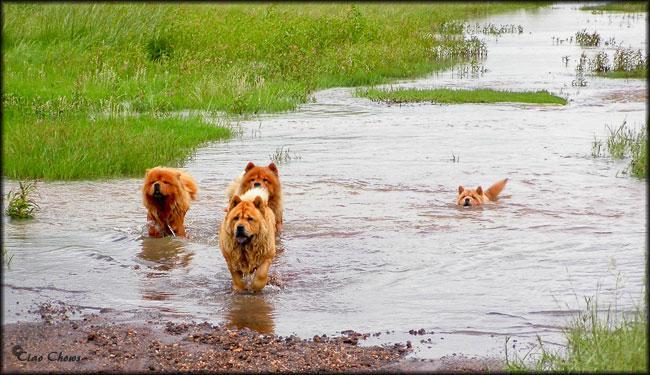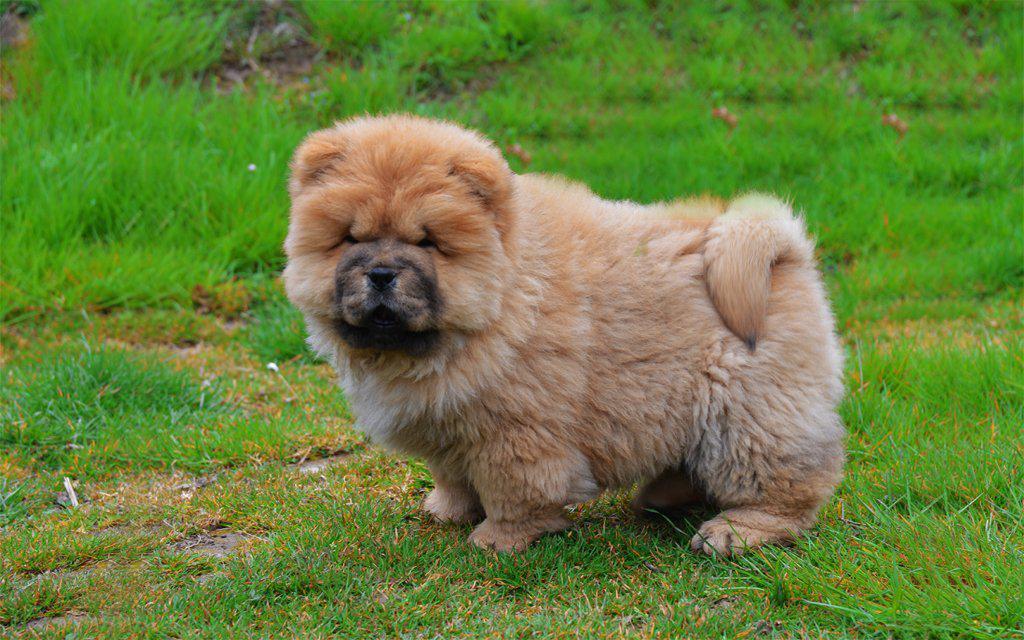The first image is the image on the left, the second image is the image on the right. Considering the images on both sides, is "One dog in the image on the right is standing on a grassy area." valid? Answer yes or no. Yes. The first image is the image on the left, the second image is the image on the right. Evaluate the accuracy of this statement regarding the images: "The left image contains exactly two dogs.". Is it true? Answer yes or no. No. 